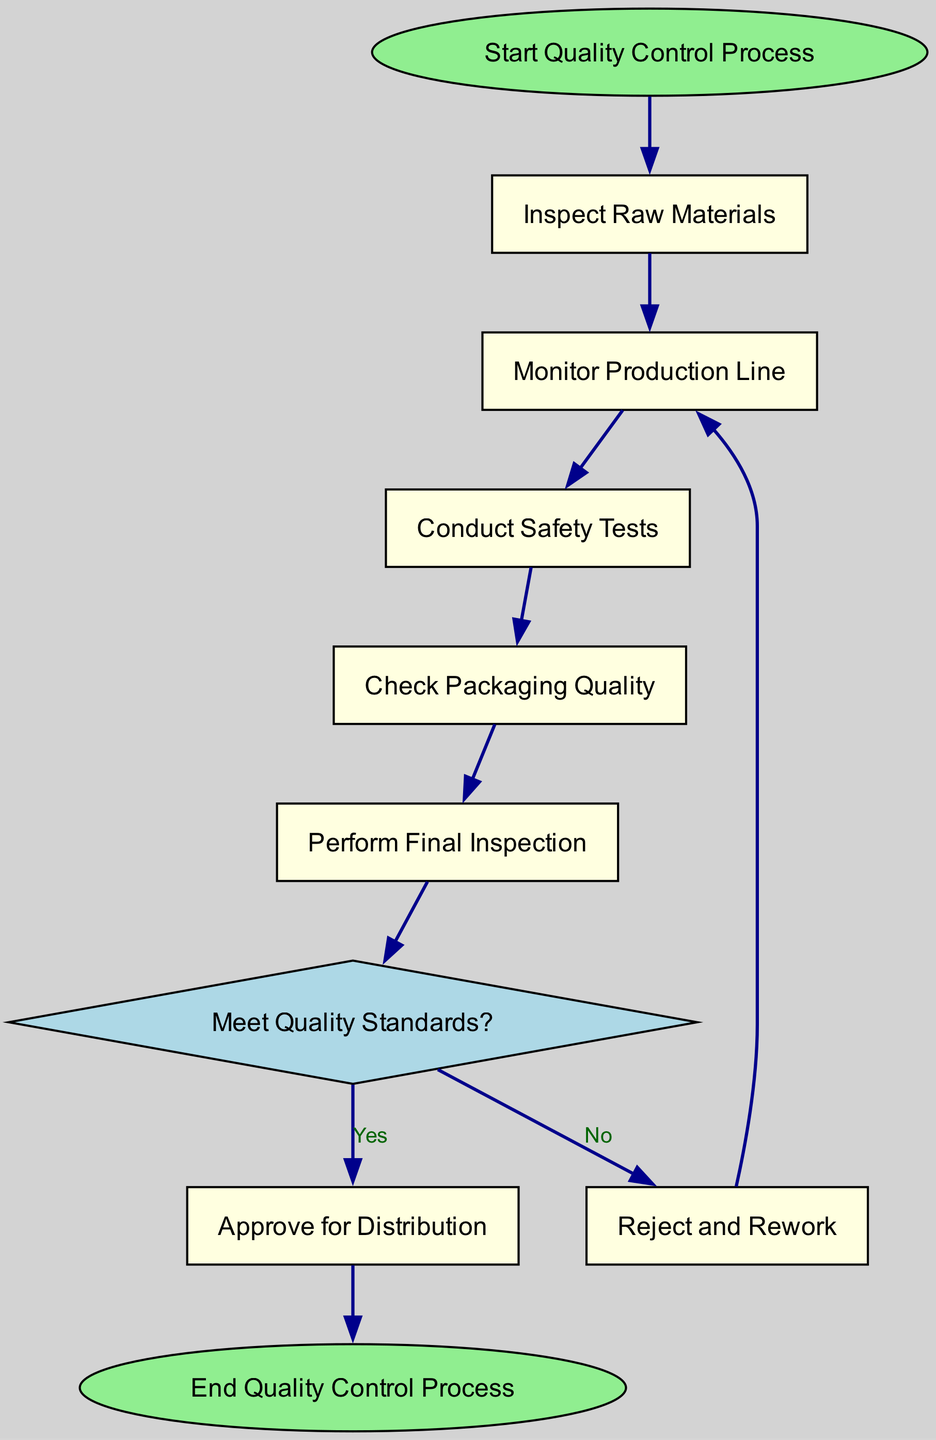What is the first step in the Quality Control Process? The diagram shows that the first node is labeled "Start Quality Control Process." Therefore, this is the initial step of the process.
Answer: Start Quality Control Process How many nodes are in the diagram? By counting all the nodes listed in the data, we find there are ten nodes: start, raw materials, production, safety test, packaging, final inspection, decision, approve, reject, and end.
Answer: 10 What shape is used for the decision node? The decision node is uniquely identified in the diagram with a diamond shape, which differentiates it from the other rectangular nodes representing actions.
Answer: Diamond What happens if the decision does not meet quality standards? The flowchart indicates that if the quality standards are not met, the process leads to the "Reject and Rework" node, which then points back to the "Monitor Production Line."
Answer: Reject and Rework What is the end point of the Quality Control Process? The last node in the flow indicates the conclusion of this process is to "End Quality Control Process," which signifies that all quality checks and approvals have been completed.
Answer: End Quality Control Process After conducting safety tests, what step follows? According to the diagram flow, after conducting "Safety Tests," the next step is to "Check Packaging Quality." This indicates a sequence of actions that flows logically in the quality control process.
Answer: Check Packaging Quality How many paths lead to the end node? There is one direct path leading from the "Approve for Distribution" node to the "End Quality Control Process." This shows that approval is the final stage of the quality control workflow.
Answer: 1 Which node is a prerequisite for forming the decision about quality standards? The diagram clearly shows that the "Perform Final Inspection" node is necessary before reaching the "Meet Quality Standards?" decision node, as it's directly preceding it in the flow.
Answer: Perform Final Inspection What color is used for the nodes representing actions? The nodes representing actions, such as "Inspect Raw Materials," "Monitor Production Line," etc., are filled with a light yellow color as indicated in the properties specified in the data.
Answer: Light yellow 